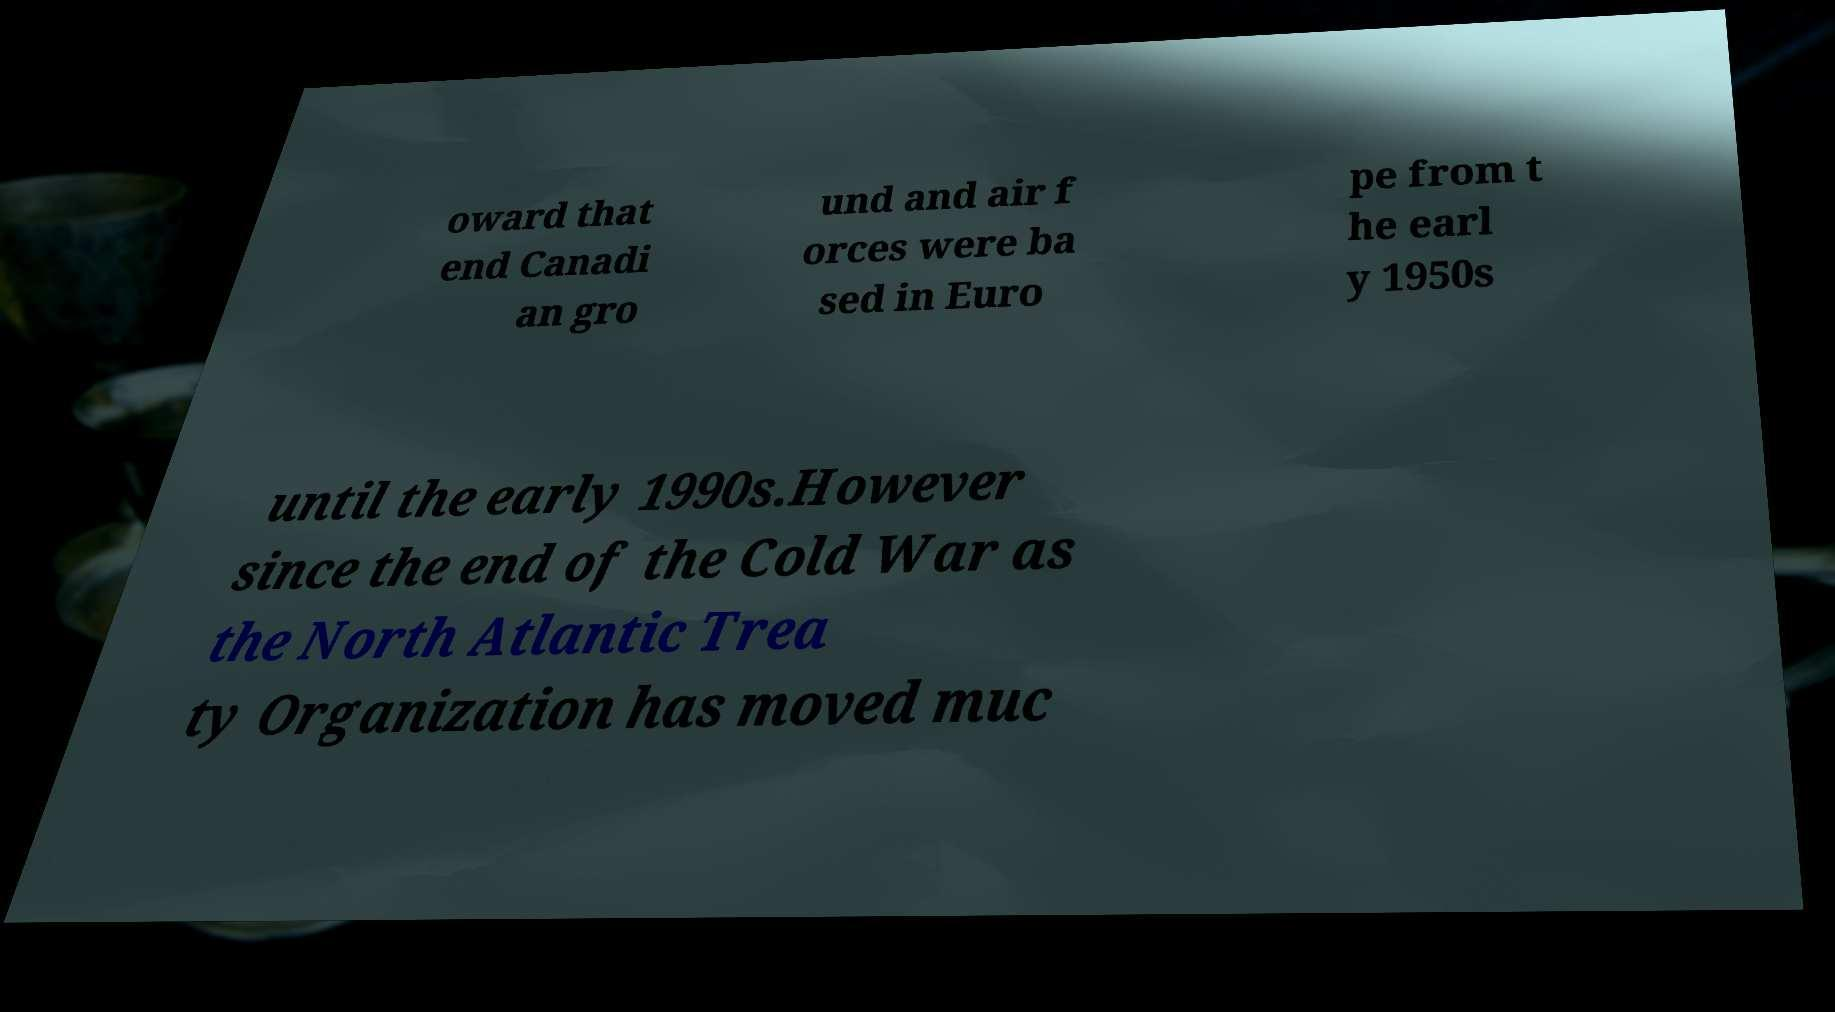Could you assist in decoding the text presented in this image and type it out clearly? oward that end Canadi an gro und and air f orces were ba sed in Euro pe from t he earl y 1950s until the early 1990s.However since the end of the Cold War as the North Atlantic Trea ty Organization has moved muc 